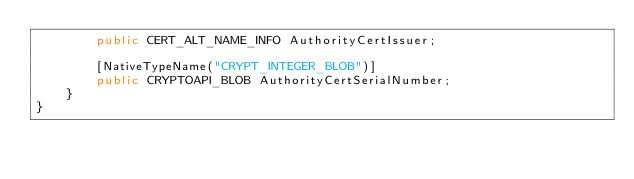<code> <loc_0><loc_0><loc_500><loc_500><_C#_>        public CERT_ALT_NAME_INFO AuthorityCertIssuer;

        [NativeTypeName("CRYPT_INTEGER_BLOB")]
        public CRYPTOAPI_BLOB AuthorityCertSerialNumber;
    }
}
</code> 